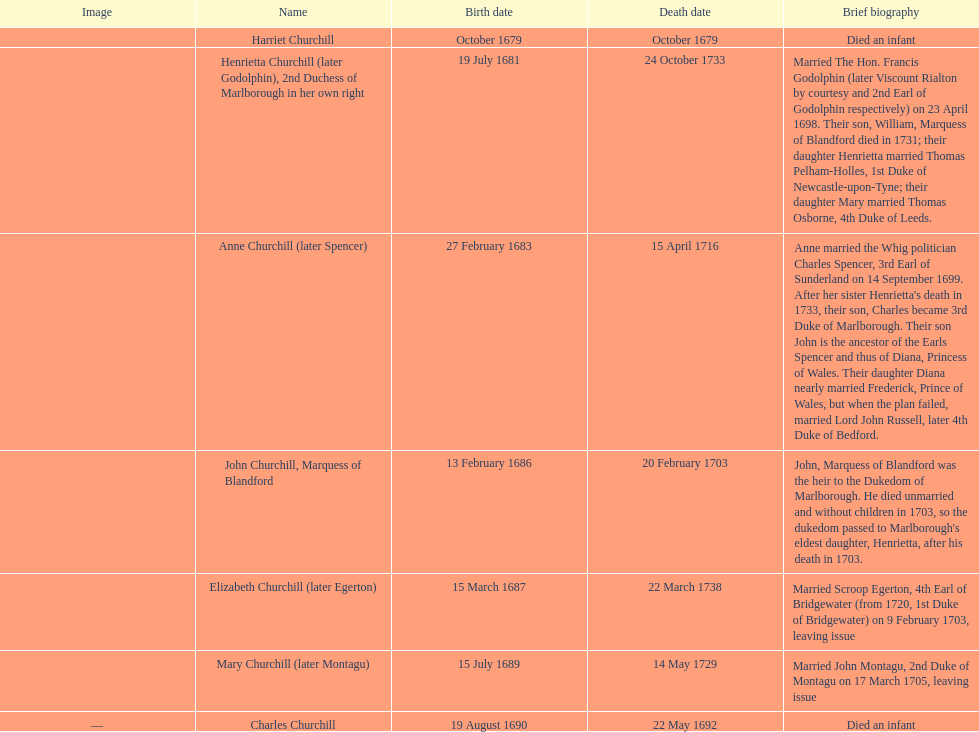When was the first child of sarah churchill born? October 1679. 